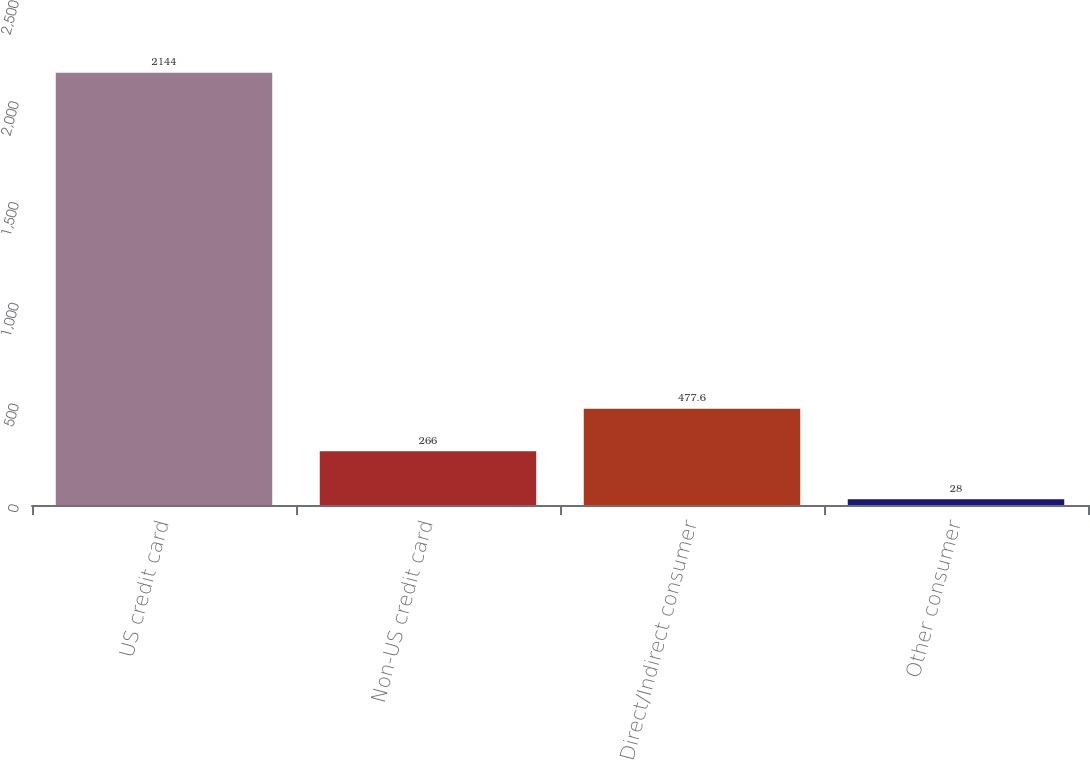Convert chart to OTSL. <chart><loc_0><loc_0><loc_500><loc_500><bar_chart><fcel>US credit card<fcel>Non-US credit card<fcel>Direct/Indirect consumer<fcel>Other consumer<nl><fcel>2144<fcel>266<fcel>477.6<fcel>28<nl></chart> 